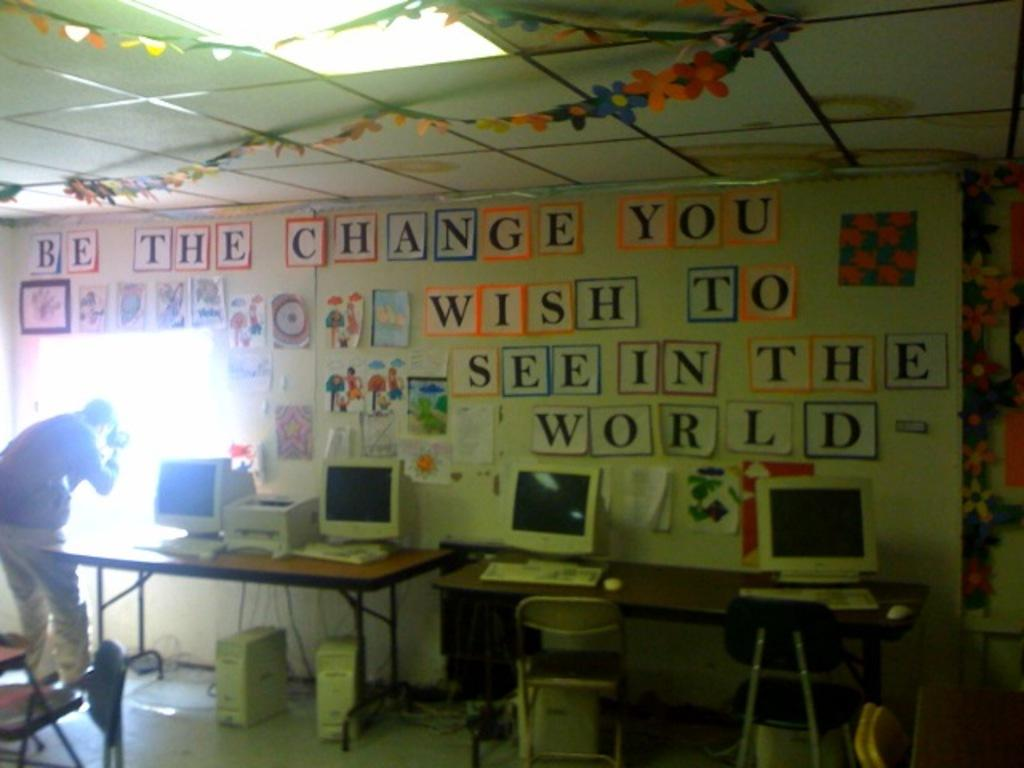What is on the wall in the image? There are stickers on the wall. What objects are on the table in the image? There are computers on a table. Who is present in the image? There is a man in the image. What is the man doing in the image? The man is looking outside. What type of plants can be seen growing on the man's head in the image? There are no plants visible on the man's head in the image. Is the man a spy in the image? There is no information in the image to suggest that the man is a spy. 